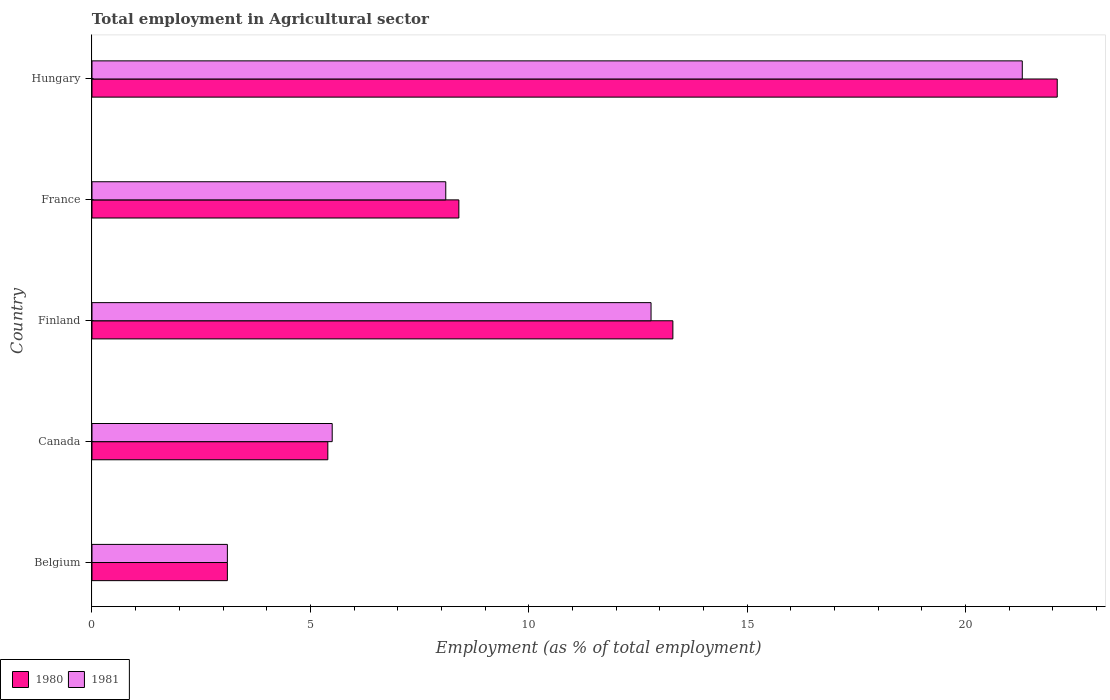How many different coloured bars are there?
Your answer should be compact. 2. How many groups of bars are there?
Ensure brevity in your answer.  5. Are the number of bars on each tick of the Y-axis equal?
Your response must be concise. Yes. How many bars are there on the 5th tick from the bottom?
Offer a very short reply. 2. What is the employment in agricultural sector in 1980 in Hungary?
Make the answer very short. 22.1. Across all countries, what is the maximum employment in agricultural sector in 1981?
Make the answer very short. 21.3. Across all countries, what is the minimum employment in agricultural sector in 1980?
Ensure brevity in your answer.  3.1. In which country was the employment in agricultural sector in 1981 maximum?
Your response must be concise. Hungary. What is the total employment in agricultural sector in 1980 in the graph?
Offer a very short reply. 52.3. What is the difference between the employment in agricultural sector in 1981 in Canada and that in Finland?
Make the answer very short. -7.3. What is the difference between the employment in agricultural sector in 1981 in Finland and the employment in agricultural sector in 1980 in France?
Make the answer very short. 4.4. What is the average employment in agricultural sector in 1981 per country?
Your answer should be very brief. 10.16. What is the ratio of the employment in agricultural sector in 1981 in Belgium to that in Canada?
Offer a very short reply. 0.56. Is the employment in agricultural sector in 1980 in Belgium less than that in Hungary?
Your answer should be very brief. Yes. Is the difference between the employment in agricultural sector in 1981 in Belgium and Canada greater than the difference between the employment in agricultural sector in 1980 in Belgium and Canada?
Your response must be concise. No. What is the difference between the highest and the second highest employment in agricultural sector in 1980?
Give a very brief answer. 8.8. What is the difference between the highest and the lowest employment in agricultural sector in 1980?
Offer a terse response. 19. Is the sum of the employment in agricultural sector in 1981 in Belgium and Canada greater than the maximum employment in agricultural sector in 1980 across all countries?
Offer a very short reply. No. What does the 2nd bar from the bottom in Belgium represents?
Your response must be concise. 1981. How many countries are there in the graph?
Ensure brevity in your answer.  5. What is the difference between two consecutive major ticks on the X-axis?
Offer a very short reply. 5. Does the graph contain grids?
Your answer should be compact. No. What is the title of the graph?
Ensure brevity in your answer.  Total employment in Agricultural sector. What is the label or title of the X-axis?
Your answer should be very brief. Employment (as % of total employment). What is the Employment (as % of total employment) of 1980 in Belgium?
Keep it short and to the point. 3.1. What is the Employment (as % of total employment) in 1981 in Belgium?
Your answer should be compact. 3.1. What is the Employment (as % of total employment) in 1980 in Canada?
Offer a very short reply. 5.4. What is the Employment (as % of total employment) in 1980 in Finland?
Offer a terse response. 13.3. What is the Employment (as % of total employment) of 1981 in Finland?
Make the answer very short. 12.8. What is the Employment (as % of total employment) of 1980 in France?
Offer a terse response. 8.4. What is the Employment (as % of total employment) of 1981 in France?
Provide a succinct answer. 8.1. What is the Employment (as % of total employment) of 1980 in Hungary?
Provide a succinct answer. 22.1. What is the Employment (as % of total employment) of 1981 in Hungary?
Provide a succinct answer. 21.3. Across all countries, what is the maximum Employment (as % of total employment) of 1980?
Offer a very short reply. 22.1. Across all countries, what is the maximum Employment (as % of total employment) in 1981?
Your answer should be very brief. 21.3. Across all countries, what is the minimum Employment (as % of total employment) of 1980?
Make the answer very short. 3.1. Across all countries, what is the minimum Employment (as % of total employment) in 1981?
Keep it short and to the point. 3.1. What is the total Employment (as % of total employment) in 1980 in the graph?
Provide a short and direct response. 52.3. What is the total Employment (as % of total employment) in 1981 in the graph?
Give a very brief answer. 50.8. What is the difference between the Employment (as % of total employment) of 1981 in Belgium and that in Canada?
Keep it short and to the point. -2.4. What is the difference between the Employment (as % of total employment) of 1980 in Belgium and that in France?
Give a very brief answer. -5.3. What is the difference between the Employment (as % of total employment) in 1981 in Belgium and that in Hungary?
Provide a succinct answer. -18.2. What is the difference between the Employment (as % of total employment) of 1981 in Canada and that in Finland?
Provide a short and direct response. -7.3. What is the difference between the Employment (as % of total employment) in 1980 in Canada and that in France?
Offer a very short reply. -3. What is the difference between the Employment (as % of total employment) of 1980 in Canada and that in Hungary?
Provide a short and direct response. -16.7. What is the difference between the Employment (as % of total employment) in 1981 in Canada and that in Hungary?
Offer a very short reply. -15.8. What is the difference between the Employment (as % of total employment) in 1980 in Finland and that in France?
Your answer should be compact. 4.9. What is the difference between the Employment (as % of total employment) of 1981 in Finland and that in France?
Make the answer very short. 4.7. What is the difference between the Employment (as % of total employment) of 1980 in Finland and that in Hungary?
Offer a terse response. -8.8. What is the difference between the Employment (as % of total employment) of 1980 in France and that in Hungary?
Make the answer very short. -13.7. What is the difference between the Employment (as % of total employment) of 1981 in France and that in Hungary?
Your response must be concise. -13.2. What is the difference between the Employment (as % of total employment) in 1980 in Belgium and the Employment (as % of total employment) in 1981 in Canada?
Your answer should be compact. -2.4. What is the difference between the Employment (as % of total employment) of 1980 in Belgium and the Employment (as % of total employment) of 1981 in Hungary?
Your response must be concise. -18.2. What is the difference between the Employment (as % of total employment) of 1980 in Canada and the Employment (as % of total employment) of 1981 in Finland?
Ensure brevity in your answer.  -7.4. What is the difference between the Employment (as % of total employment) of 1980 in Canada and the Employment (as % of total employment) of 1981 in France?
Your answer should be very brief. -2.7. What is the difference between the Employment (as % of total employment) in 1980 in Canada and the Employment (as % of total employment) in 1981 in Hungary?
Your answer should be very brief. -15.9. What is the average Employment (as % of total employment) of 1980 per country?
Provide a succinct answer. 10.46. What is the average Employment (as % of total employment) of 1981 per country?
Your answer should be very brief. 10.16. What is the difference between the Employment (as % of total employment) of 1980 and Employment (as % of total employment) of 1981 in France?
Give a very brief answer. 0.3. What is the difference between the Employment (as % of total employment) of 1980 and Employment (as % of total employment) of 1981 in Hungary?
Offer a very short reply. 0.8. What is the ratio of the Employment (as % of total employment) in 1980 in Belgium to that in Canada?
Provide a short and direct response. 0.57. What is the ratio of the Employment (as % of total employment) of 1981 in Belgium to that in Canada?
Give a very brief answer. 0.56. What is the ratio of the Employment (as % of total employment) of 1980 in Belgium to that in Finland?
Give a very brief answer. 0.23. What is the ratio of the Employment (as % of total employment) in 1981 in Belgium to that in Finland?
Provide a short and direct response. 0.24. What is the ratio of the Employment (as % of total employment) of 1980 in Belgium to that in France?
Give a very brief answer. 0.37. What is the ratio of the Employment (as % of total employment) of 1981 in Belgium to that in France?
Keep it short and to the point. 0.38. What is the ratio of the Employment (as % of total employment) in 1980 in Belgium to that in Hungary?
Your answer should be very brief. 0.14. What is the ratio of the Employment (as % of total employment) of 1981 in Belgium to that in Hungary?
Ensure brevity in your answer.  0.15. What is the ratio of the Employment (as % of total employment) of 1980 in Canada to that in Finland?
Your answer should be very brief. 0.41. What is the ratio of the Employment (as % of total employment) of 1981 in Canada to that in Finland?
Offer a terse response. 0.43. What is the ratio of the Employment (as % of total employment) of 1980 in Canada to that in France?
Ensure brevity in your answer.  0.64. What is the ratio of the Employment (as % of total employment) in 1981 in Canada to that in France?
Your answer should be compact. 0.68. What is the ratio of the Employment (as % of total employment) of 1980 in Canada to that in Hungary?
Provide a short and direct response. 0.24. What is the ratio of the Employment (as % of total employment) of 1981 in Canada to that in Hungary?
Make the answer very short. 0.26. What is the ratio of the Employment (as % of total employment) in 1980 in Finland to that in France?
Your answer should be very brief. 1.58. What is the ratio of the Employment (as % of total employment) of 1981 in Finland to that in France?
Ensure brevity in your answer.  1.58. What is the ratio of the Employment (as % of total employment) in 1980 in Finland to that in Hungary?
Your answer should be compact. 0.6. What is the ratio of the Employment (as % of total employment) in 1981 in Finland to that in Hungary?
Offer a very short reply. 0.6. What is the ratio of the Employment (as % of total employment) of 1980 in France to that in Hungary?
Your answer should be very brief. 0.38. What is the ratio of the Employment (as % of total employment) in 1981 in France to that in Hungary?
Your answer should be very brief. 0.38. What is the difference between the highest and the second highest Employment (as % of total employment) in 1980?
Offer a terse response. 8.8. What is the difference between the highest and the lowest Employment (as % of total employment) in 1980?
Provide a succinct answer. 19. What is the difference between the highest and the lowest Employment (as % of total employment) of 1981?
Provide a short and direct response. 18.2. 